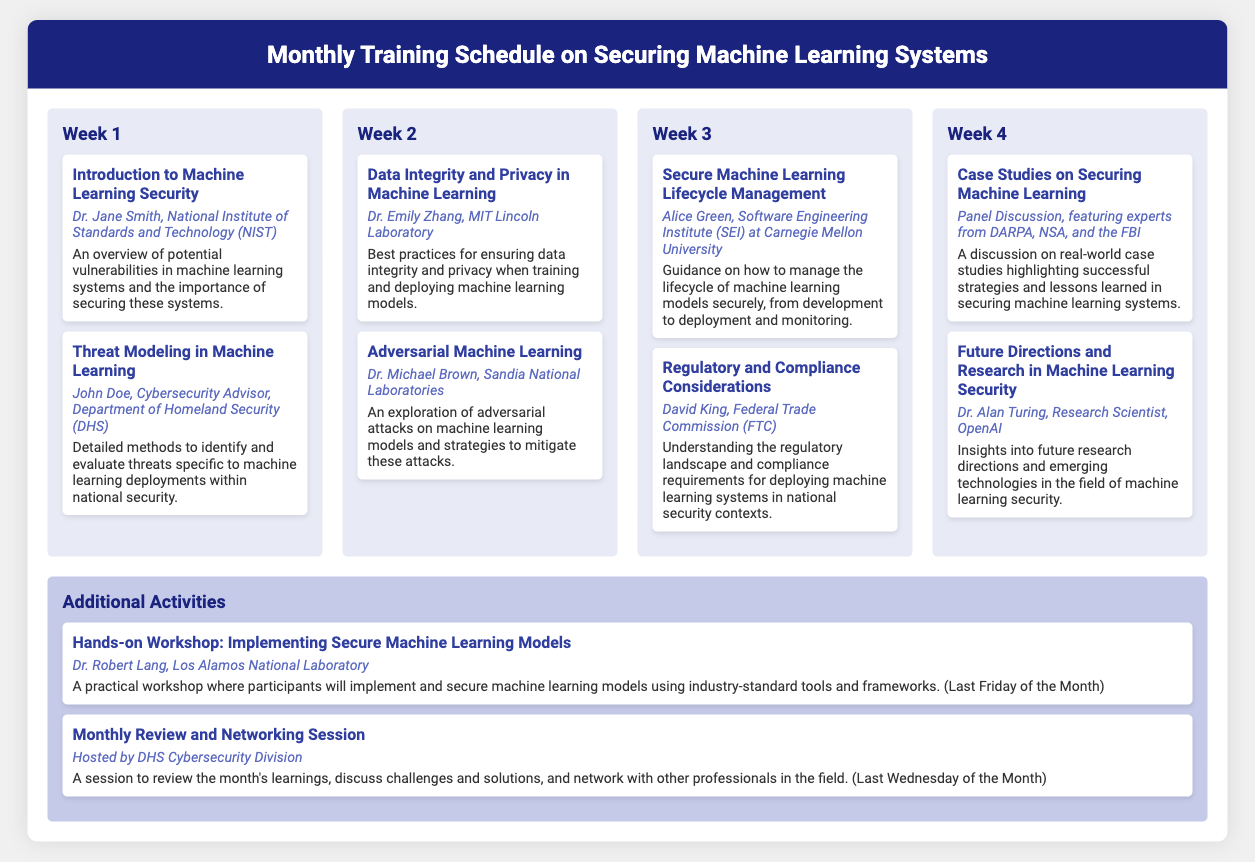what is the title of the first topic in Week 1? The first topic in Week 1 is identified by its title in the document.
Answer: Introduction to Machine Learning Security who is the presenter for the topic on Threat Modeling in Machine Learning? The presenter is listed beneath the topic title in the document.
Answer: John Doe, Cybersecurity Advisor, Department of Homeland Security (DHS) what week covers the topic on Data Integrity and Privacy in Machine Learning? The week can be determined by the order of topics in the document for the corresponding title.
Answer: Week 2 how many topics are presented in Week 3? The total topics in that week can be counted based on the weeks' layout in the document.
Answer: 2 which organization is represented by Dr. Michael Brown? The organization is mentioned along with the presenter's name in the document.
Answer: Sandia National Laboratories what is the subject of the last topic in Week 4? The subject can be found as the title of the last topic in that week.
Answer: Future Directions and Research in Machine Learning Security when is the hands-on workshop scheduled? The timing of the workshop is given in the description associated with it in the document.
Answer: Last Friday of the Month who hosts the Monthly Review and Networking Session? The host is specified in the details of the session in the document.
Answer: Hosted by DHS Cybersecurity Division 